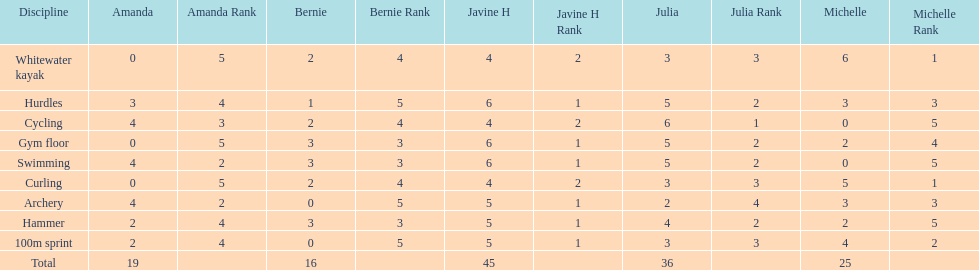Who had her best score in cycling? Julia. 